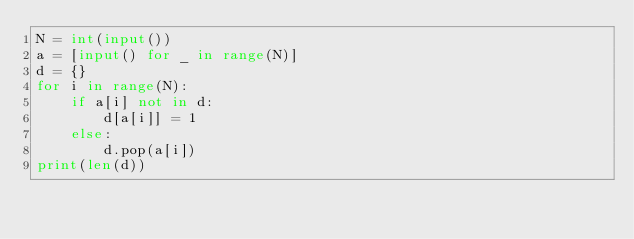<code> <loc_0><loc_0><loc_500><loc_500><_Python_>N = int(input())
a = [input() for _ in range(N)]
d = {}
for i in range(N):
    if a[i] not in d:
        d[a[i]] = 1
    else:
        d.pop(a[i])
print(len(d))
</code> 